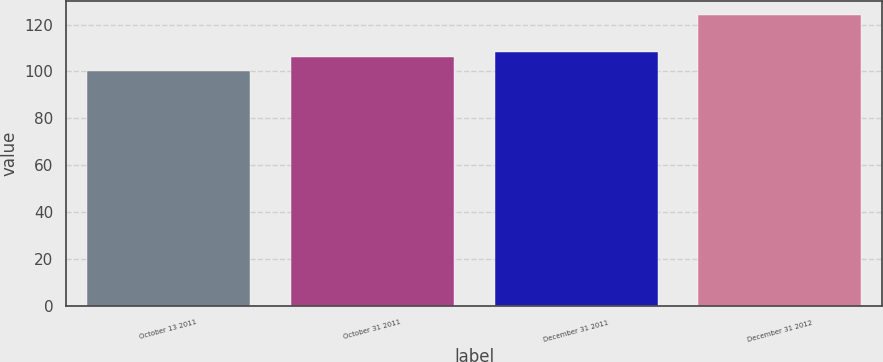Convert chart to OTSL. <chart><loc_0><loc_0><loc_500><loc_500><bar_chart><fcel>October 13 2011<fcel>October 31 2011<fcel>December 31 2011<fcel>December 31 2012<nl><fcel>100<fcel>106<fcel>108.4<fcel>124<nl></chart> 